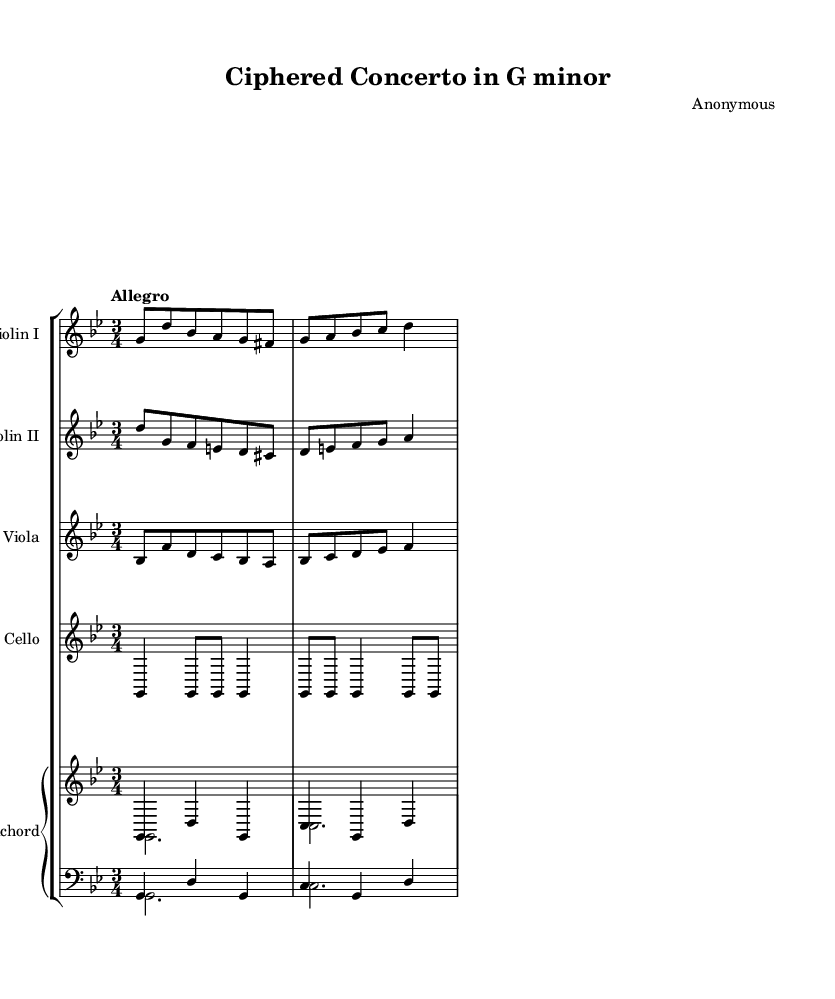What is the key signature of this music? The key signature is G minor, indicated by two flats in the key signature.
Answer: G minor What is the time signature of this piece? The time signature is 3/4, as shown at the beginning of the staff.
Answer: 3/4 What is the tempo marking for this concerto? The tempo marking is "Allegro," indicating a fast and lively tempo.
Answer: Allegro How many instruments are featured in this composition? The composition features five instruments: two violins, one viola, one cello, and one harpsichord.
Answer: Five What rhythmic pattern is used in the cello part? The cello part includes an embedded Morse code rhythm representing the word 'CIPHER', which consists of a sequence of quarter notes and eighth notes.
Answer: Morse code Which instrument has the most prominent upper voice? The first violin part has the most prominent upper voice, as it often carries the main melody in a concerto.
Answer: Violin I What does the harpsichord part primarily serve as in this piece? The harpsichord part serves as both harmonic support and the creation of a figured bass line, typical in Baroque ensembles.
Answer: Harmonic support 